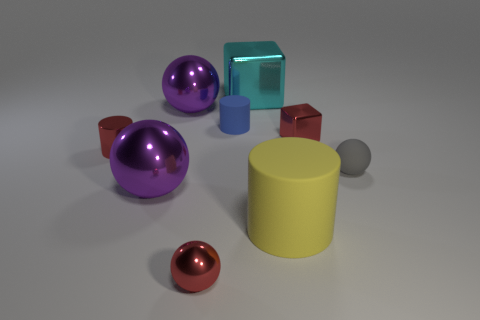There is a red shiny object that is the same shape as the gray object; what is its size?
Make the answer very short. Small. What shape is the tiny thing that is both on the right side of the blue thing and on the left side of the gray rubber object?
Give a very brief answer. Cube. There is a gray object; does it have the same size as the block in front of the large cyan metal cube?
Offer a very short reply. Yes. The other small object that is the same shape as the gray thing is what color?
Offer a terse response. Red. There is a purple metal thing that is in front of the tiny red block; is it the same size as the rubber thing that is on the left side of the yellow object?
Provide a short and direct response. No. Is the shape of the big matte thing the same as the small blue object?
Make the answer very short. Yes. How many things are either small objects right of the big yellow rubber thing or big blocks?
Provide a succinct answer. 3. Are there any small purple things that have the same shape as the tiny blue thing?
Your answer should be very brief. No. Is the number of cyan shiny blocks that are to the left of the blue rubber thing the same as the number of large blue matte objects?
Provide a short and direct response. Yes. What number of red objects are the same size as the gray ball?
Your answer should be very brief. 3. 